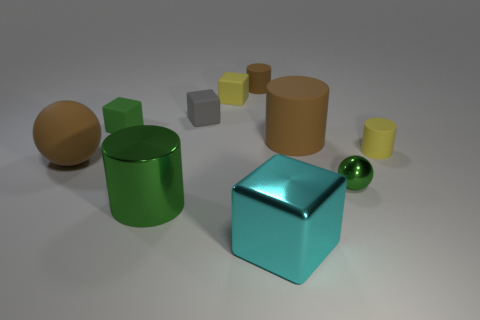Subtract all balls. How many objects are left? 8 Subtract all red rubber cubes. Subtract all tiny yellow blocks. How many objects are left? 9 Add 4 large cyan objects. How many large cyan objects are left? 5 Add 5 big green cylinders. How many big green cylinders exist? 6 Subtract 1 yellow cylinders. How many objects are left? 9 